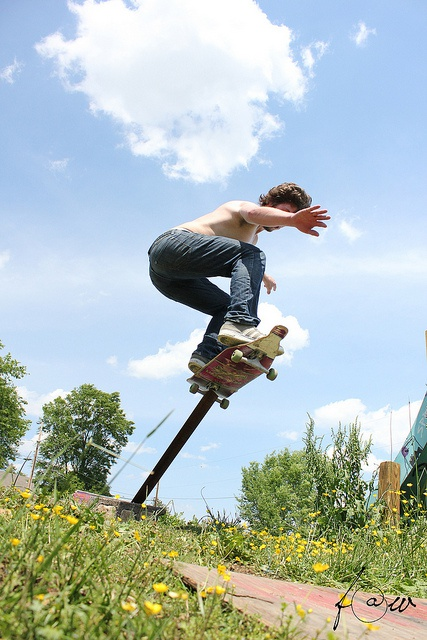Describe the objects in this image and their specific colors. I can see people in lightblue, black, white, gray, and darkgray tones and skateboard in lightblue, maroon, black, olive, and gray tones in this image. 